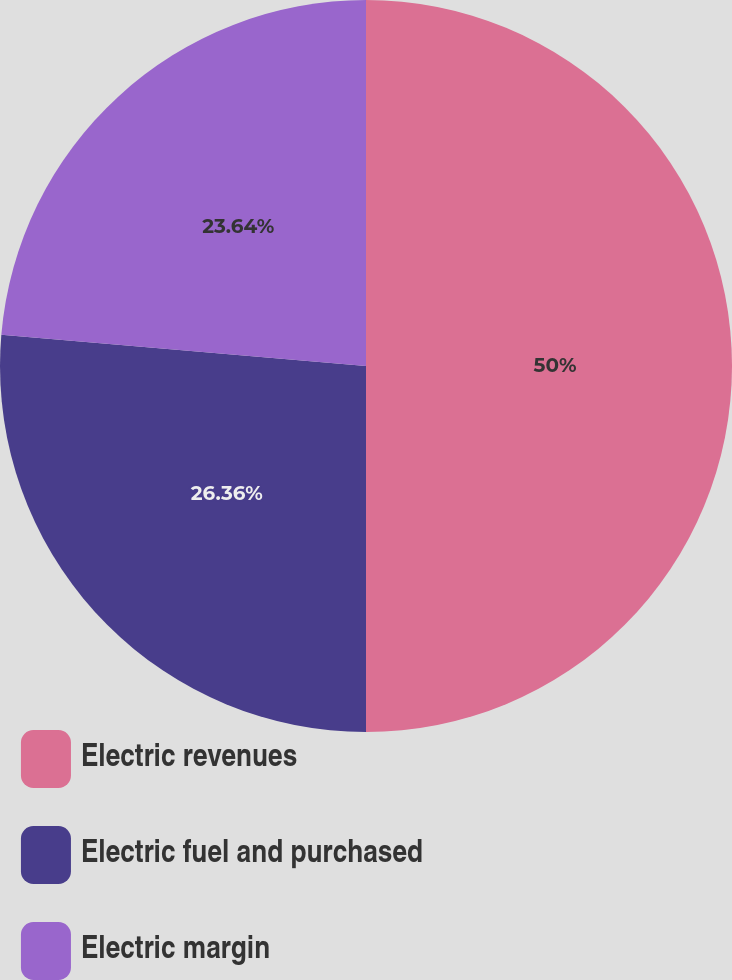Convert chart. <chart><loc_0><loc_0><loc_500><loc_500><pie_chart><fcel>Electric revenues<fcel>Electric fuel and purchased<fcel>Electric margin<nl><fcel>50.0%<fcel>26.36%<fcel>23.64%<nl></chart> 